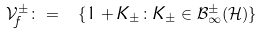Convert formula to latex. <formula><loc_0><loc_0><loc_500><loc_500>\mathcal { V } _ { f } ^ { \pm } \colon = \ \{ 1 + K _ { \pm } \colon K _ { \pm } \in \mathcal { B } _ { \infty } ^ { \pm } ( \mathcal { H } ) \}</formula> 